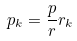Convert formula to latex. <formula><loc_0><loc_0><loc_500><loc_500>p _ { k } = \frac { p } { r } r _ { k }</formula> 